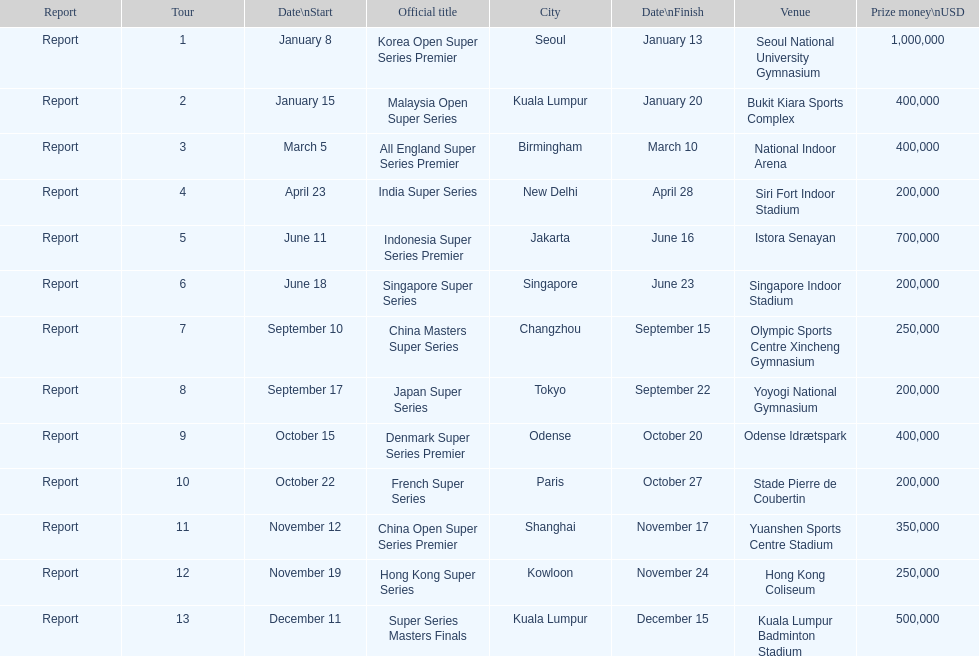Write the full table. {'header': ['Report', 'Tour', 'Date\\nStart', 'Official title', 'City', 'Date\\nFinish', 'Venue', 'Prize money\\nUSD'], 'rows': [['Report', '1', 'January 8', 'Korea Open Super Series Premier', 'Seoul', 'January 13', 'Seoul National University Gymnasium', '1,000,000'], ['Report', '2', 'January 15', 'Malaysia Open Super Series', 'Kuala Lumpur', 'January 20', 'Bukit Kiara Sports Complex', '400,000'], ['Report', '3', 'March 5', 'All England Super Series Premier', 'Birmingham', 'March 10', 'National Indoor Arena', '400,000'], ['Report', '4', 'April 23', 'India Super Series', 'New Delhi', 'April 28', 'Siri Fort Indoor Stadium', '200,000'], ['Report', '5', 'June 11', 'Indonesia Super Series Premier', 'Jakarta', 'June 16', 'Istora Senayan', '700,000'], ['Report', '6', 'June 18', 'Singapore Super Series', 'Singapore', 'June 23', 'Singapore Indoor Stadium', '200,000'], ['Report', '7', 'September 10', 'China Masters Super Series', 'Changzhou', 'September 15', 'Olympic Sports Centre Xincheng Gymnasium', '250,000'], ['Report', '8', 'September 17', 'Japan Super Series', 'Tokyo', 'September 22', 'Yoyogi National Gymnasium', '200,000'], ['Report', '9', 'October 15', 'Denmark Super Series Premier', 'Odense', 'October 20', 'Odense Idrætspark', '400,000'], ['Report', '10', 'October 22', 'French Super Series', 'Paris', 'October 27', 'Stade Pierre de Coubertin', '200,000'], ['Report', '11', 'November 12', 'China Open Super Series Premier', 'Shanghai', 'November 17', 'Yuanshen Sports Centre Stadium', '350,000'], ['Report', '12', 'November 19', 'Hong Kong Super Series', 'Kowloon', 'November 24', 'Hong Kong Coliseum', '250,000'], ['Report', '13', 'December 11', 'Super Series Masters Finals', 'Kuala Lumpur', 'December 15', 'Kuala Lumpur Badminton Stadium', '500,000']]} How many series awarded at least $500,000 in prize money? 3. 